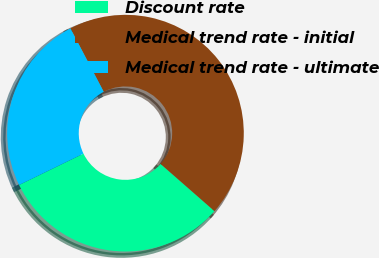<chart> <loc_0><loc_0><loc_500><loc_500><pie_chart><fcel>Discount rate<fcel>Medical trend rate - initial<fcel>Medical trend rate - ultimate<nl><fcel>31.34%<fcel>44.14%<fcel>24.52%<nl></chart> 